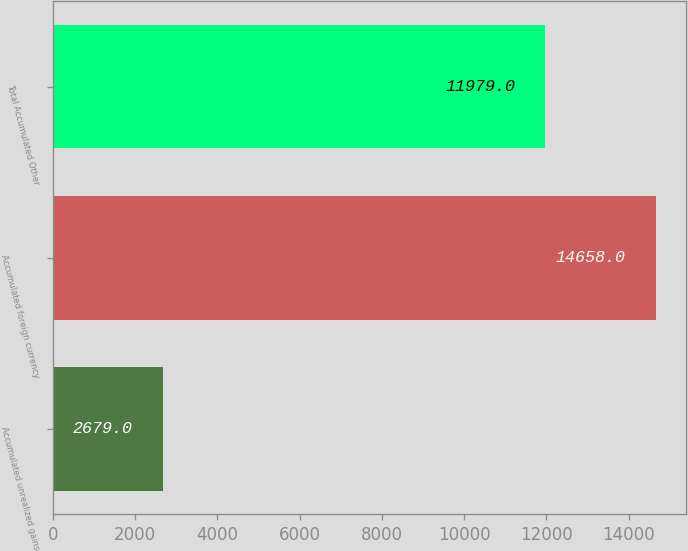Convert chart. <chart><loc_0><loc_0><loc_500><loc_500><bar_chart><fcel>Accumulated unrealized gains<fcel>Accumulated foreign currency<fcel>Total Accumulated Other<nl><fcel>2679<fcel>14658<fcel>11979<nl></chart> 